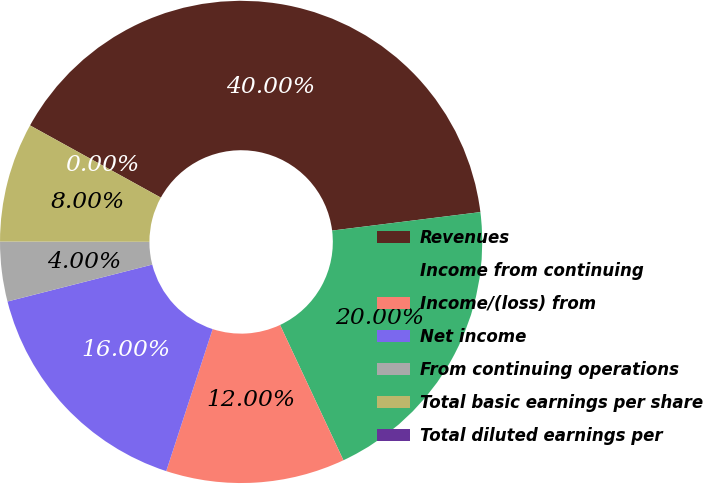Convert chart. <chart><loc_0><loc_0><loc_500><loc_500><pie_chart><fcel>Revenues<fcel>Income from continuing<fcel>Income/(loss) from<fcel>Net income<fcel>From continuing operations<fcel>Total basic earnings per share<fcel>Total diluted earnings per<nl><fcel>40.0%<fcel>20.0%<fcel>12.0%<fcel>16.0%<fcel>4.0%<fcel>8.0%<fcel>0.0%<nl></chart> 